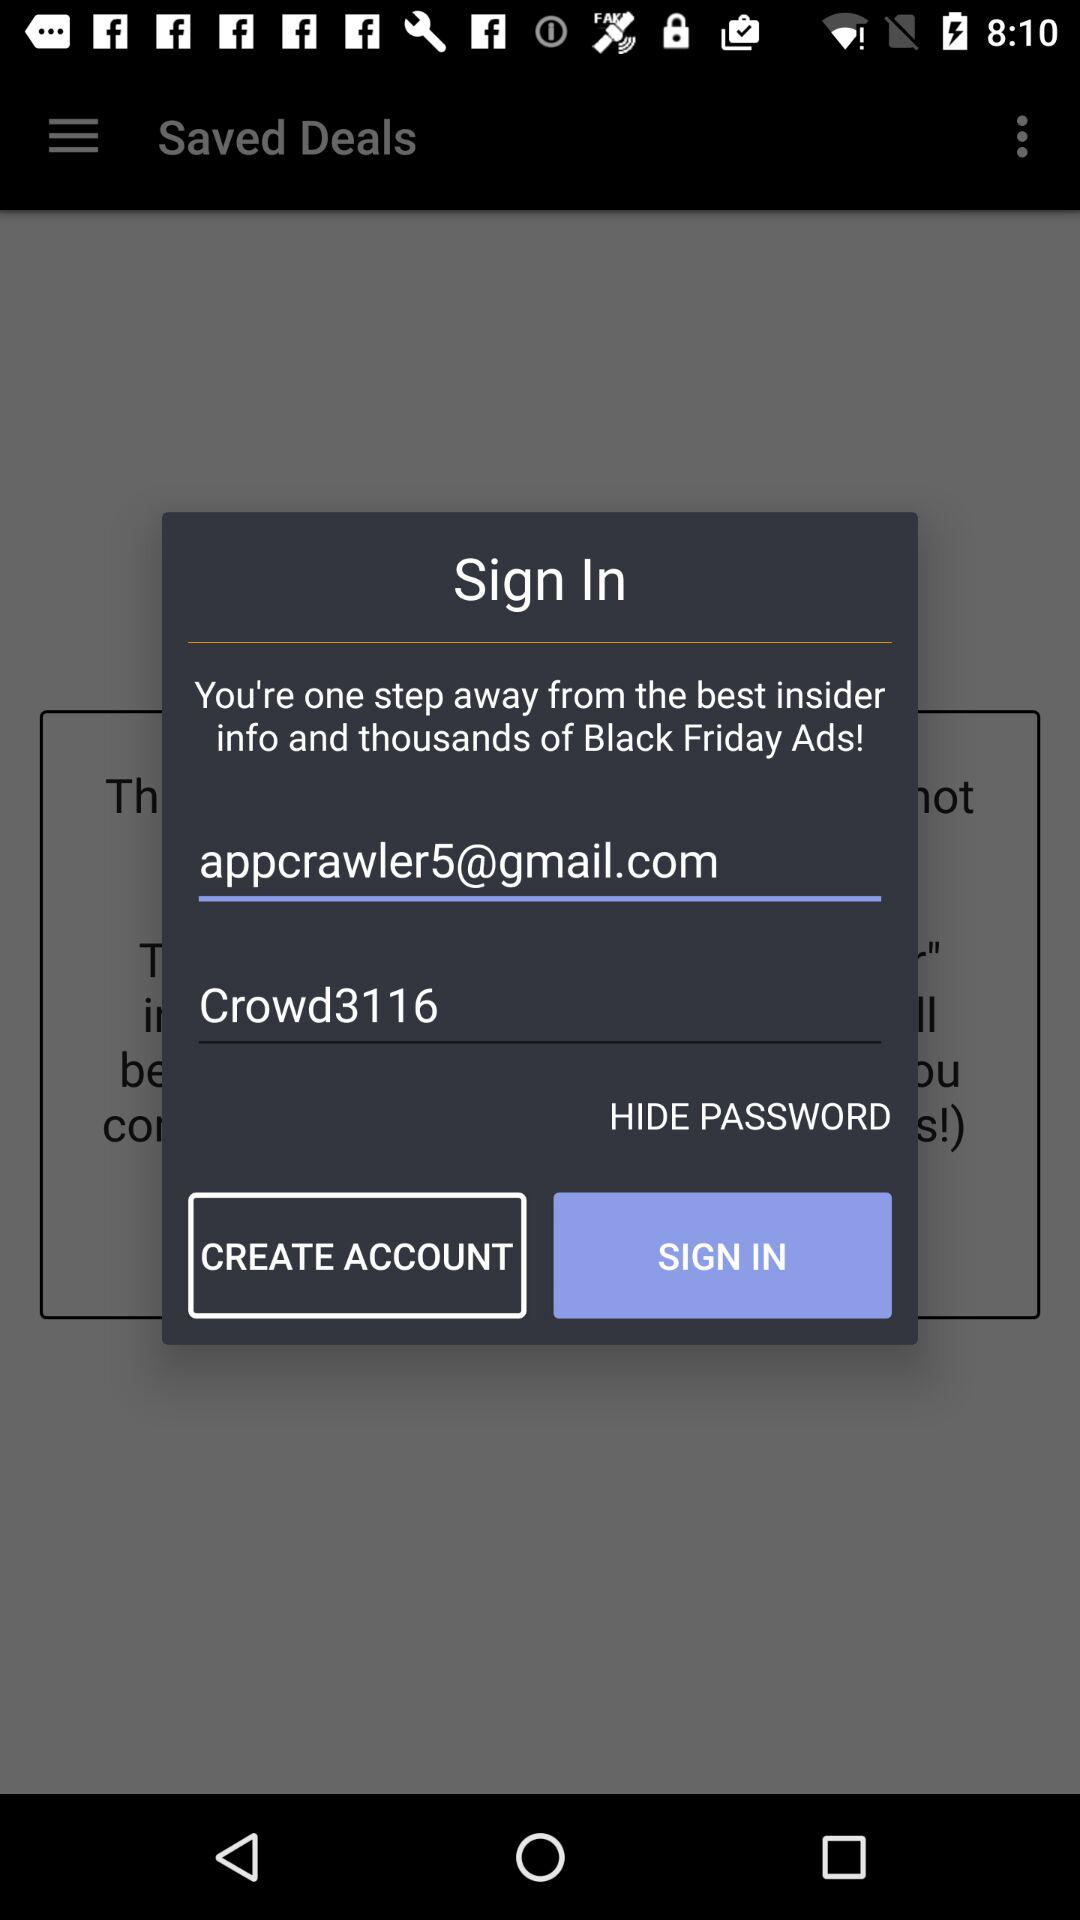What is the email address? The email address is appcrawler5@gmail.com. 